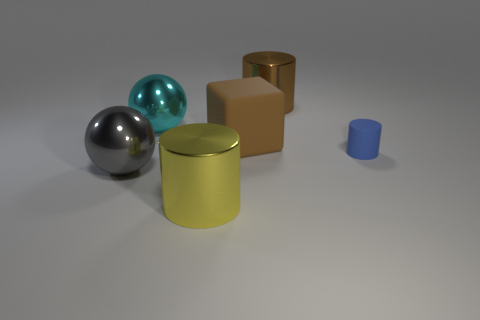What number of things are either big matte objects or objects on the right side of the gray ball?
Offer a very short reply. 5. Is there a tiny matte thing that is on the left side of the large sphere that is behind the tiny matte cylinder?
Give a very brief answer. No. What is the color of the large cylinder behind the gray thing?
Offer a very short reply. Brown. Are there the same number of yellow shiny cylinders that are behind the big matte object and big balls?
Give a very brief answer. No. There is a metallic object that is in front of the large rubber cube and behind the yellow cylinder; what is its shape?
Your answer should be compact. Sphere. What is the color of the other shiny thing that is the same shape as the large brown metal object?
Your answer should be compact. Yellow. Are there any other things that have the same color as the large cube?
Your answer should be compact. Yes. There is a cyan object behind the small blue cylinder behind the large cylinder in front of the small blue thing; what is its shape?
Offer a very short reply. Sphere. Do the cylinder behind the cyan object and the shiny cylinder in front of the rubber cylinder have the same size?
Your answer should be very brief. Yes. How many big red cylinders are the same material as the blue cylinder?
Make the answer very short. 0. 